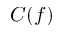Convert formula to latex. <formula><loc_0><loc_0><loc_500><loc_500>C ( f )</formula> 